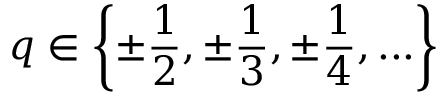<formula> <loc_0><loc_0><loc_500><loc_500>q \in \left \{ \pm { \frac { 1 } { 2 } } , \pm { \frac { 1 } { 3 } } , \pm { \frac { 1 } { 4 } } , \dots \right \}</formula> 